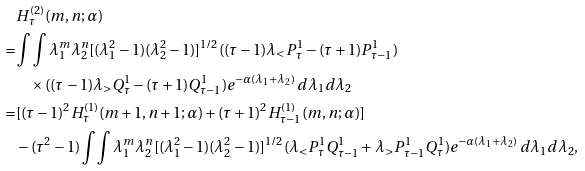<formula> <loc_0><loc_0><loc_500><loc_500>& H ^ { ( 2 ) } _ { \tau } ( m , n ; \alpha ) \\ = & \int \int \lambda _ { 1 } ^ { m } \lambda _ { 2 } ^ { n } [ ( \lambda _ { 1 } ^ { 2 } - 1 ) ( \lambda _ { 2 } ^ { 2 } - 1 ) ] ^ { 1 / 2 } ( ( \tau - 1 ) \lambda _ { < } P ^ { 1 } _ { \tau } - ( \tau + 1 ) P ^ { 1 } _ { \tau - 1 } ) \\ & \quad \times ( ( \tau - 1 ) \lambda _ { > } Q ^ { 1 } _ { \tau } - ( \tau + 1 ) Q ^ { 1 } _ { \tau - 1 } ) e ^ { - \alpha ( \lambda _ { 1 } + \lambda _ { 2 } ) } \, d \lambda _ { 1 } d \lambda _ { 2 } \\ = & [ ( \tau - 1 ) ^ { 2 } H ^ { ( 1 ) } _ { \tau } ( m + 1 , n + 1 ; \alpha ) + ( \tau + 1 ) ^ { 2 } H ^ { ( 1 ) } _ { \tau - 1 } ( m , n ; \alpha ) ] \\ & - ( \tau ^ { 2 } - 1 ) \int \int \lambda _ { 1 } ^ { m } \lambda _ { 2 } ^ { n } [ ( \lambda _ { 1 } ^ { 2 } - 1 ) ( \lambda _ { 2 } ^ { 2 } - 1 ) ] ^ { 1 / 2 } ( \lambda _ { < } P ^ { 1 } _ { \tau } Q ^ { 1 } _ { \tau - 1 } + \lambda _ { > } P ^ { 1 } _ { \tau - 1 } Q ^ { 1 } _ { \tau } ) e ^ { - \alpha ( \lambda _ { 1 } + \lambda _ { 2 } ) } \, d \lambda _ { 1 } d \lambda _ { 2 } ,</formula> 